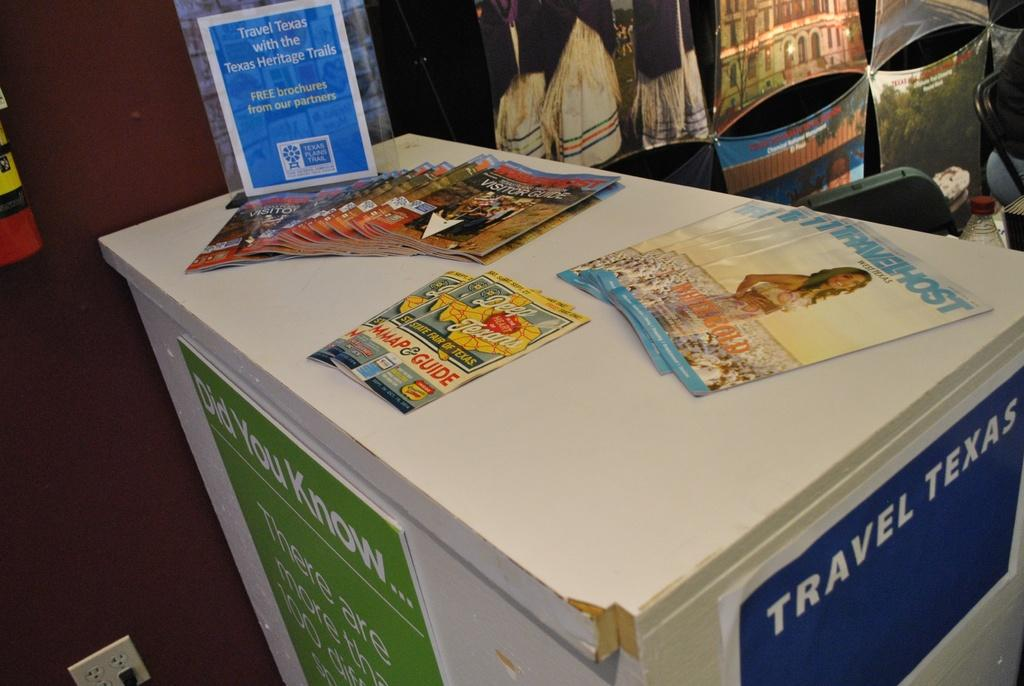Provide a one-sentence caption for the provided image. A white table has stacks of magazines on it including Travel Host. 